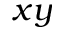Convert formula to latex. <formula><loc_0><loc_0><loc_500><loc_500>x y</formula> 